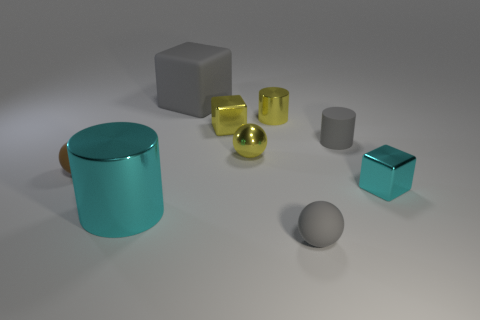Subtract all blocks. How many objects are left? 6 Subtract 0 green blocks. How many objects are left? 9 Subtract all small yellow metal objects. Subtract all tiny matte blocks. How many objects are left? 6 Add 4 tiny gray objects. How many tiny gray objects are left? 6 Add 7 small yellow balls. How many small yellow balls exist? 8 